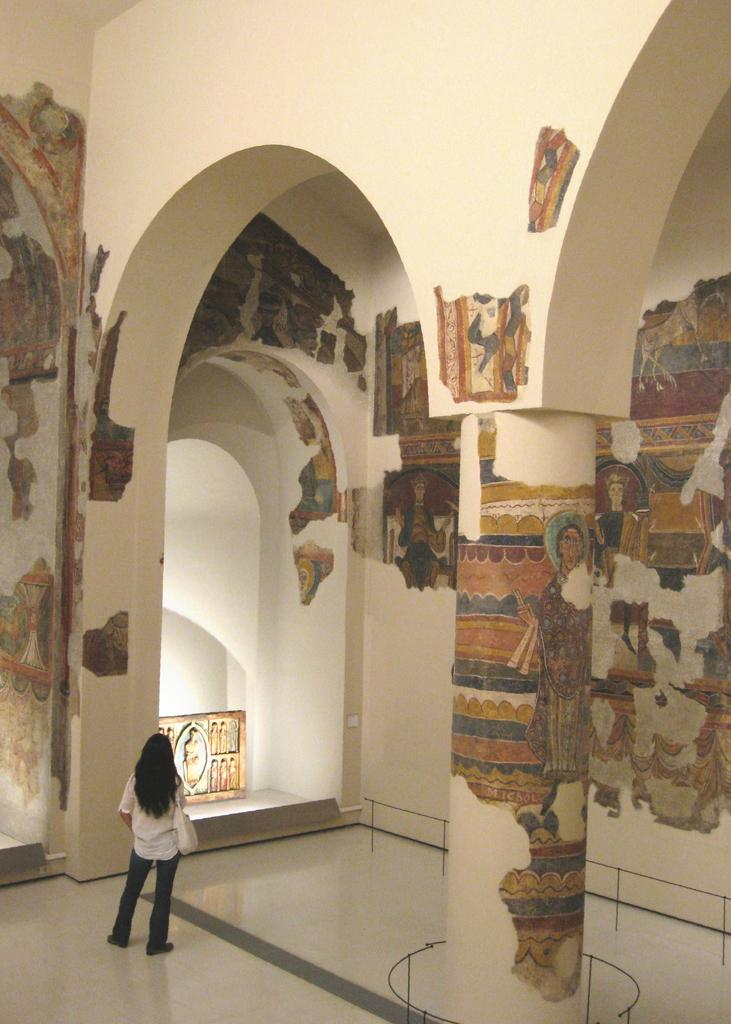What is the main subject in the center of the image? There is a woman standing in the center of the image. What can be seen on the right side of the image? There are paintings on the right side of the image, on the wall. What is located in the center of the image, besides the woman? There is a railing in the center of the image. What type of stove is visible in the image? There is no stove present in the image. 